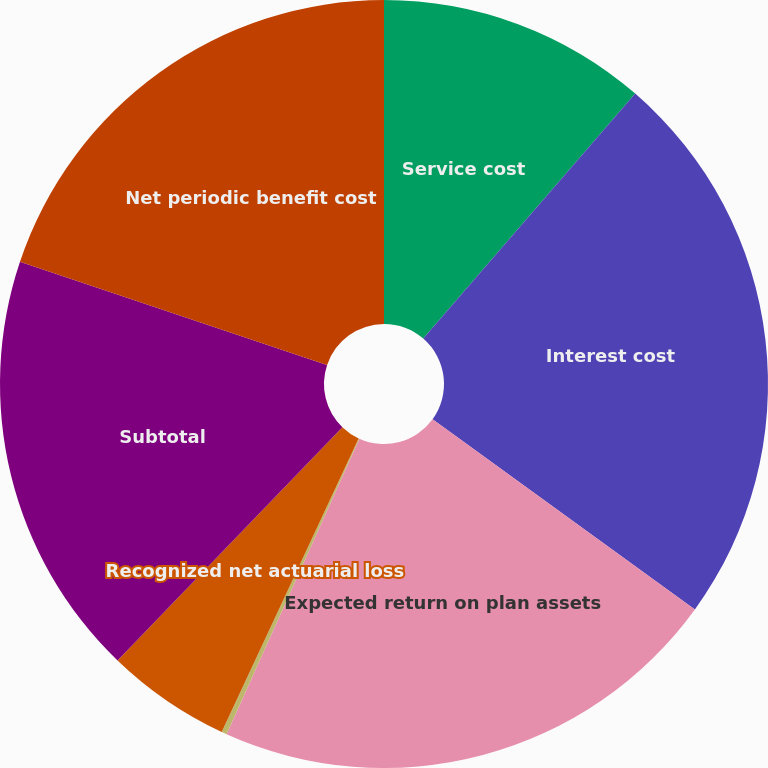Convert chart. <chart><loc_0><loc_0><loc_500><loc_500><pie_chart><fcel>Service cost<fcel>Interest cost<fcel>Expected return on plan assets<fcel>Amortization of prior service<fcel>Recognized net actuarial loss<fcel>Subtotal<fcel>Net periodic benefit cost<nl><fcel>11.35%<fcel>23.63%<fcel>21.74%<fcel>0.22%<fcel>5.26%<fcel>17.95%<fcel>19.84%<nl></chart> 